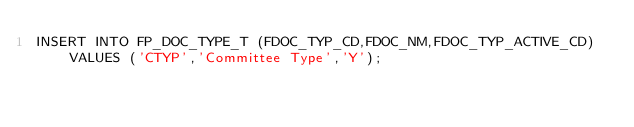<code> <loc_0><loc_0><loc_500><loc_500><_SQL_>INSERT INTO FP_DOC_TYPE_T (FDOC_TYP_CD,FDOC_NM,FDOC_TYP_ACTIVE_CD) VALUES ('CTYP','Committee Type','Y');</code> 